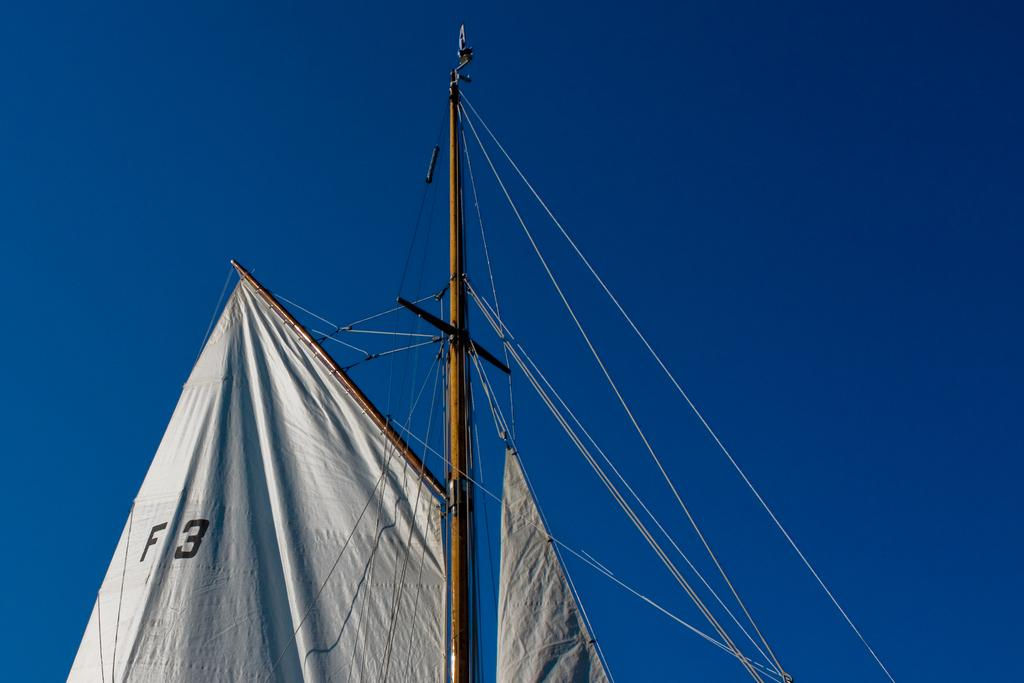<image>
Provide a brief description of the given image. White sail which has the numner and letter F3 on it. 